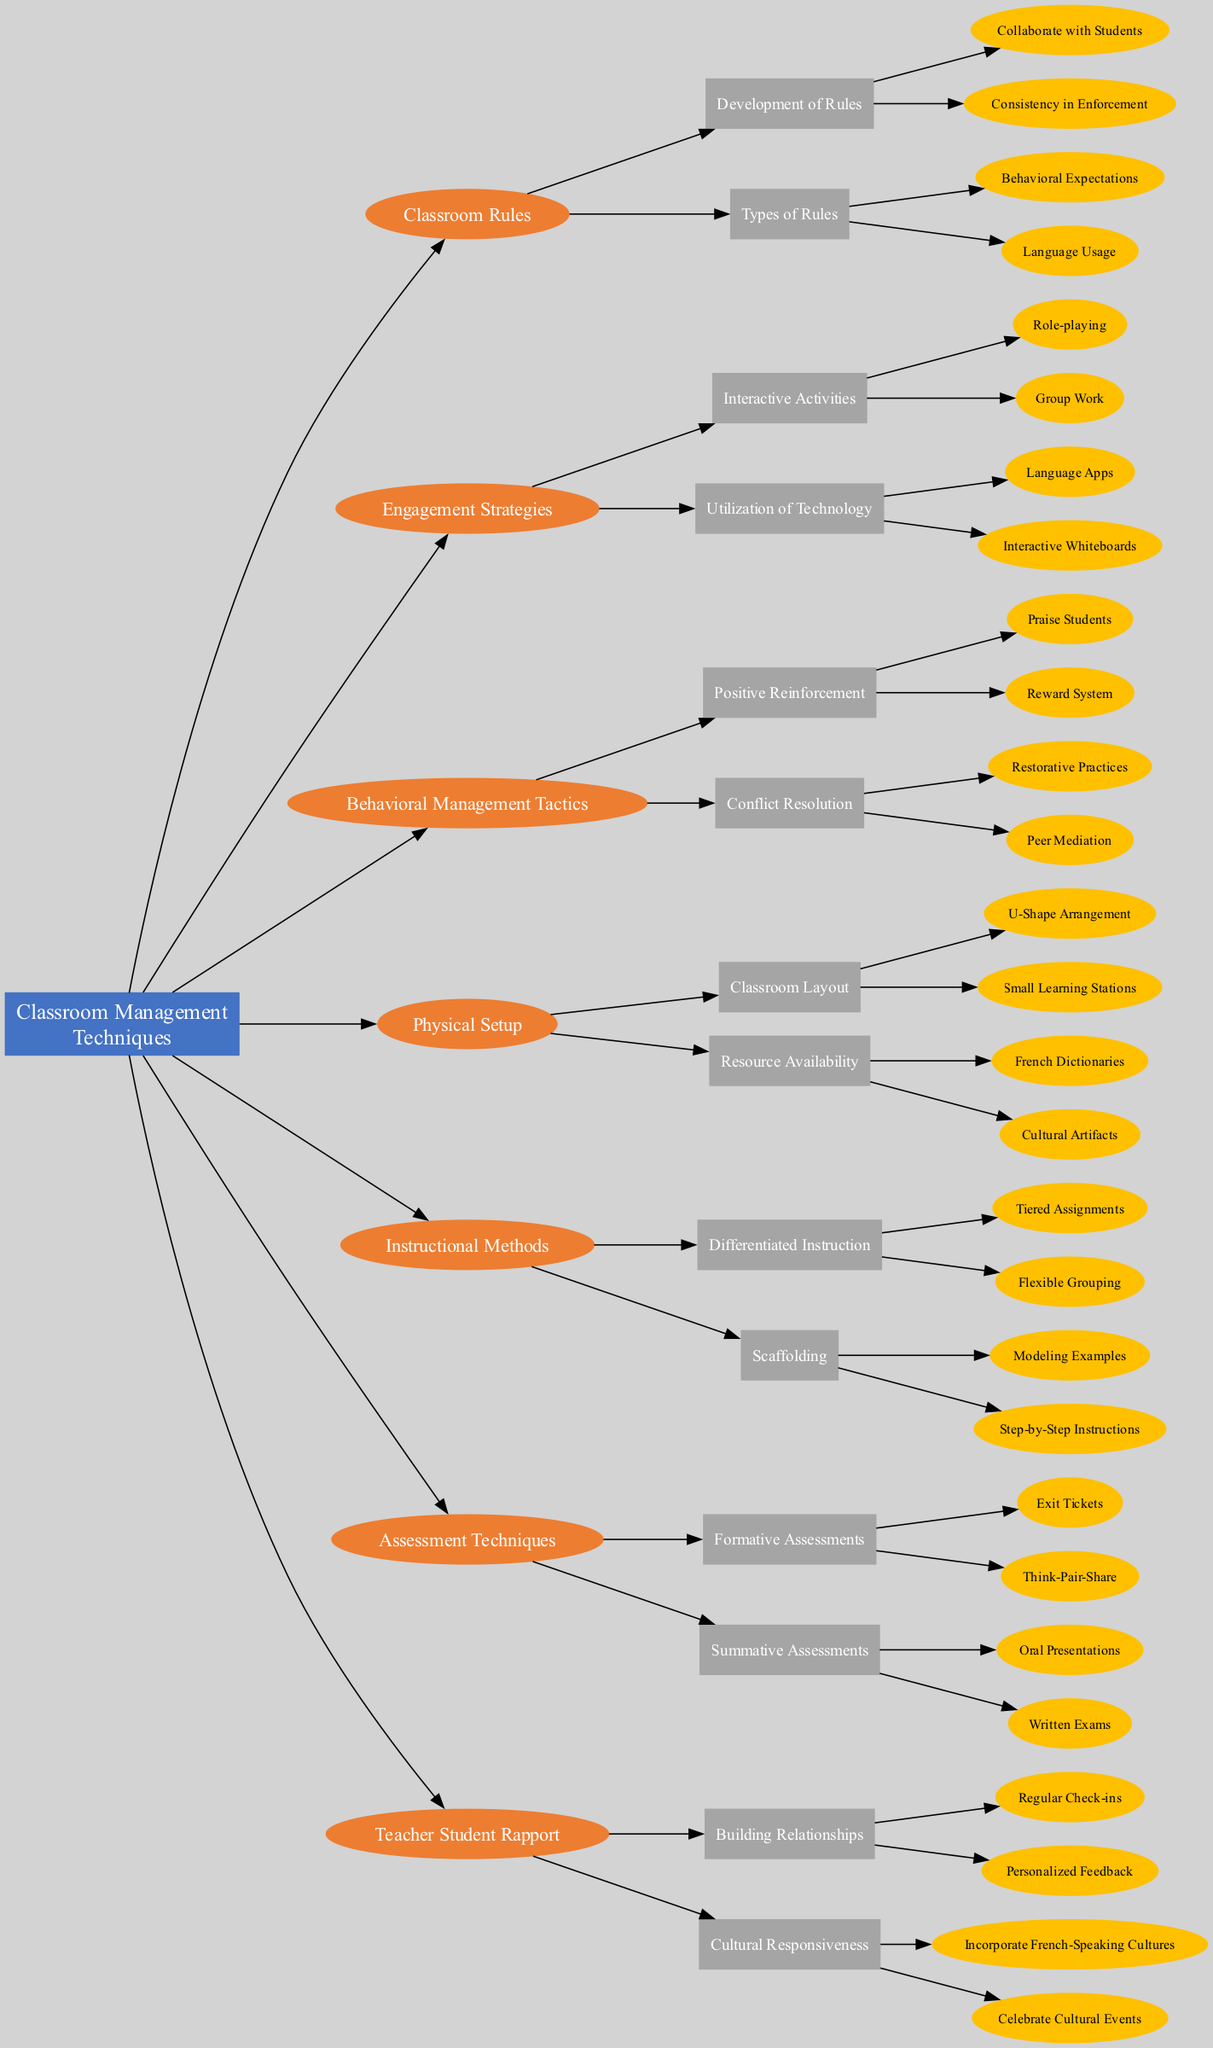What is the main node of the diagram? The main node, labeled as "Classroom Management Techniques," is at the top, representing the overall theme of the concept map. This node connects all other nodes in the diagram.
Answer: Classroom Management Techniques How many types of engagement strategies are listed in the diagram? There are two types of engagement strategies listed: Interactive Activities and Utilization of Technology, showing a total of two distinct categories.
Answer: 2 Which behavioral management tactic includes both "Praise Students" and "Reward System"? The tactic that includes both "Praise Students" and "Reward System" is categorized under Positive Reinforcement, showing how this specific tactic promotes positive behaviors in the classroom.
Answer: Positive Reinforcement What is one method used in "Differentiated Instruction"? One method used in "Differentiated Instruction" is "Tiered Assignments," which allows teachers to provide various levels of challenge based on student abilities.
Answer: Tiered Assignments How are "Regular Check-ins" and "Personalized Feedback" related in the context of teacher-student rapport? "Regular Check-ins" and "Personalized Feedback" are both strategies used under Building Relationships, highlighting the importance of ongoing communication for fostering positive relations in the classroom.
Answer: Building Relationships What resource is included in the physical setup of the classroom? The resource included in the physical setup is "French Dictionaries," which serves as a valuable tool for students to reference during language lessons.
Answer: French Dictionaries Which engagement strategy incorporates "Language Apps"? The engagement strategy that incorporates "Language Apps" falls under Utilization of Technology, emphasizing the use of modern tools to enhance learning.
Answer: Utilization of Technology What are the two categories of classroom rules mentioned in the diagram? The two categories of classroom rules mentioned are Behavioral Expectations and Language Usage, which represent the different aspects that are regulated within the classroom environment.
Answer: Behavioral Expectations and Language Usage 